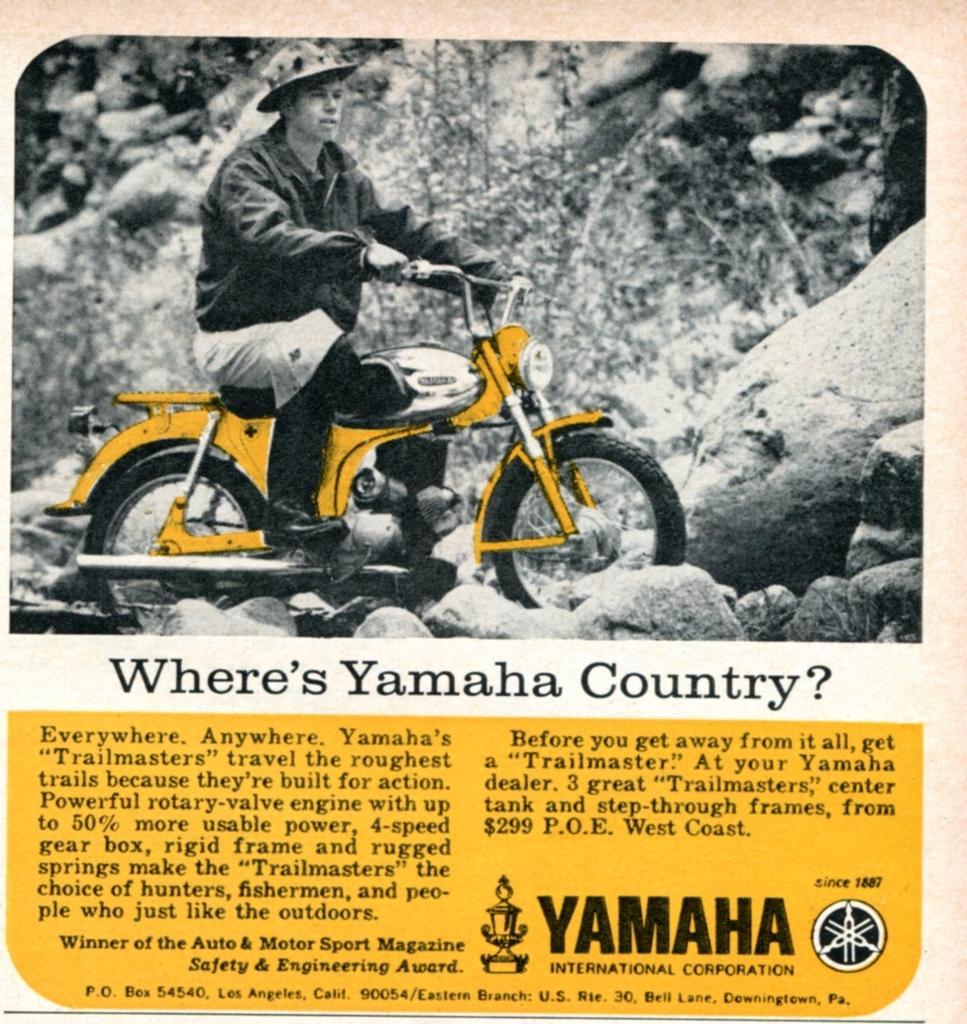Can you describe this image briefly? In the image we can see one man riding bike and he is wearing hat. In the background there is a stone and plant. 